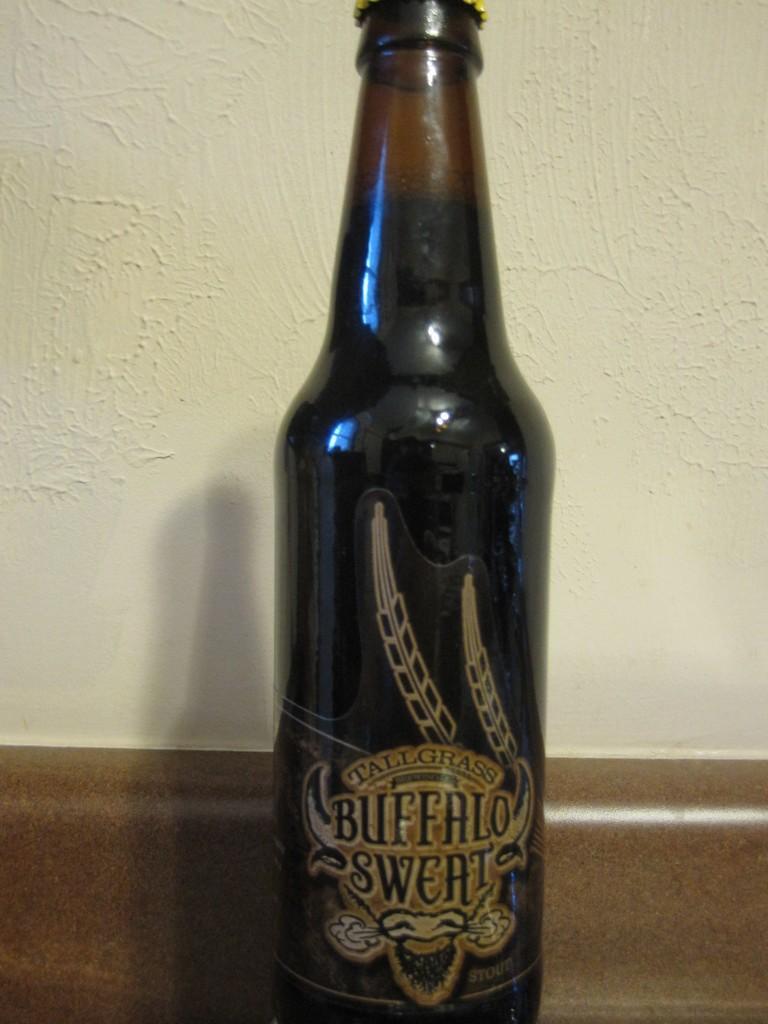Could you give a brief overview of what you see in this image? In the picture there is a bottle it is written as "buffalo sweat" on the bottle is of black color, in the background there is a wall. 